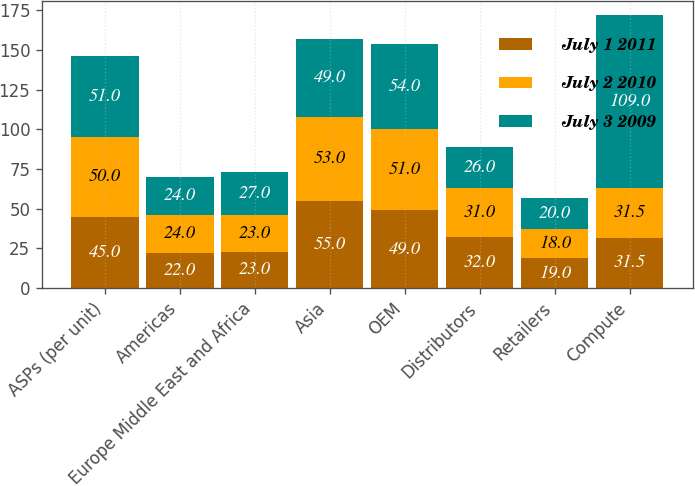Convert chart to OTSL. <chart><loc_0><loc_0><loc_500><loc_500><stacked_bar_chart><ecel><fcel>ASPs (per unit)<fcel>Americas<fcel>Europe Middle East and Africa<fcel>Asia<fcel>OEM<fcel>Distributors<fcel>Retailers<fcel>Compute<nl><fcel>July 1 2011<fcel>45<fcel>22<fcel>23<fcel>55<fcel>49<fcel>32<fcel>19<fcel>31.5<nl><fcel>July 2 2010<fcel>50<fcel>24<fcel>23<fcel>53<fcel>51<fcel>31<fcel>18<fcel>31.5<nl><fcel>July 3 2009<fcel>51<fcel>24<fcel>27<fcel>49<fcel>54<fcel>26<fcel>20<fcel>109<nl></chart> 